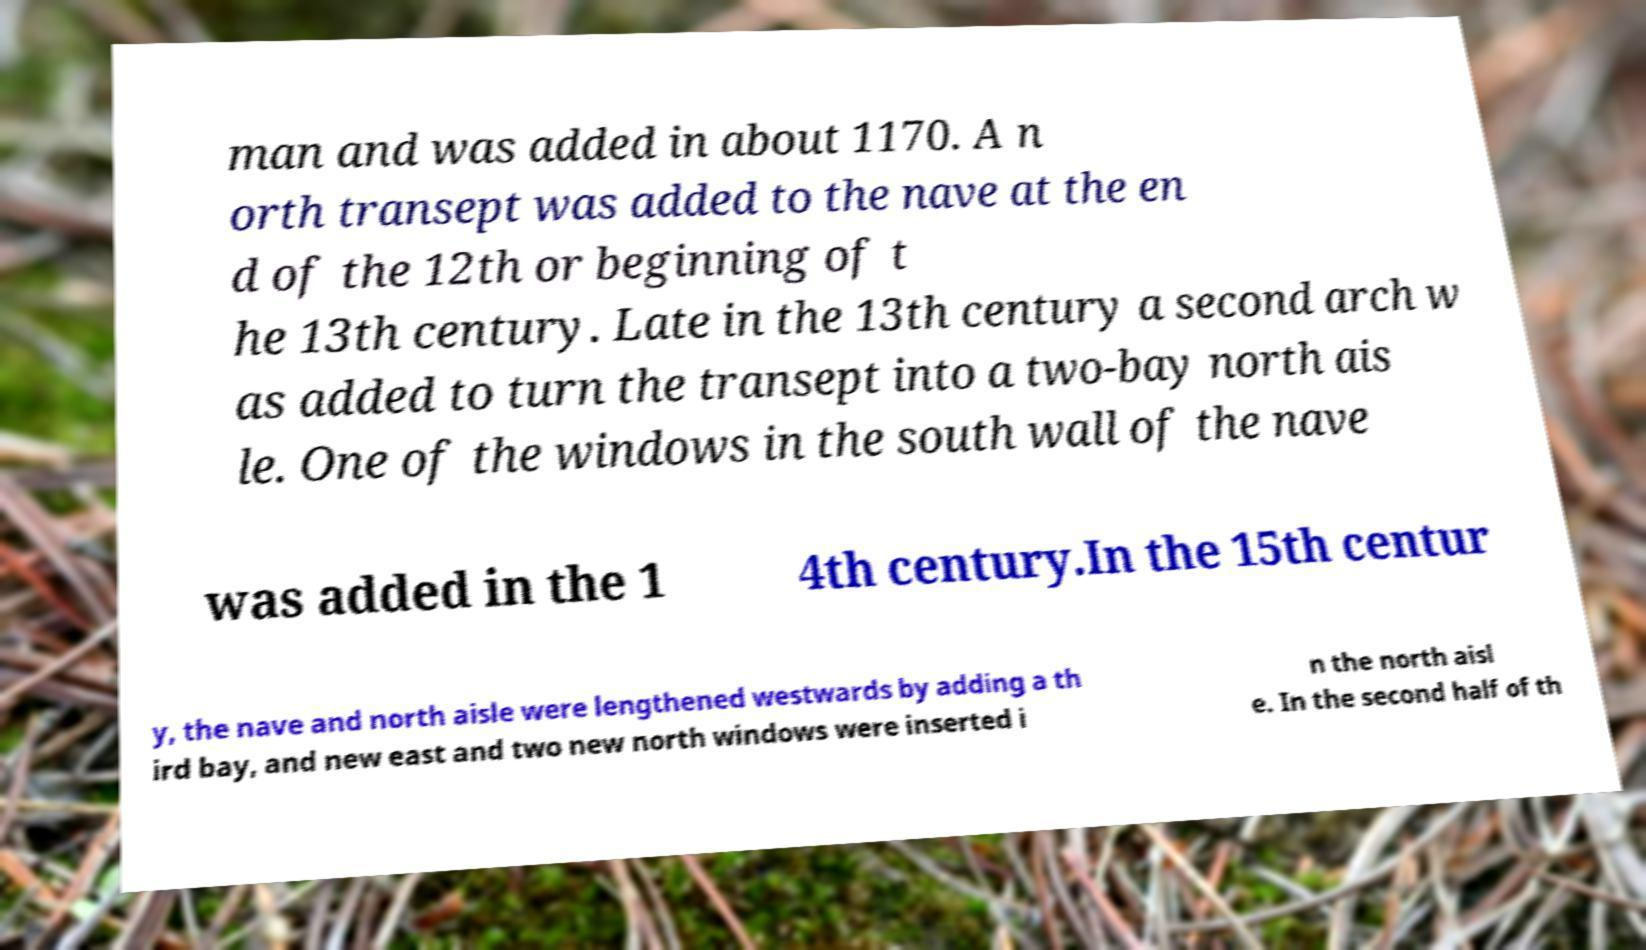Can you accurately transcribe the text from the provided image for me? man and was added in about 1170. A n orth transept was added to the nave at the en d of the 12th or beginning of t he 13th century. Late in the 13th century a second arch w as added to turn the transept into a two-bay north ais le. One of the windows in the south wall of the nave was added in the 1 4th century.In the 15th centur y, the nave and north aisle were lengthened westwards by adding a th ird bay, and new east and two new north windows were inserted i n the north aisl e. In the second half of th 